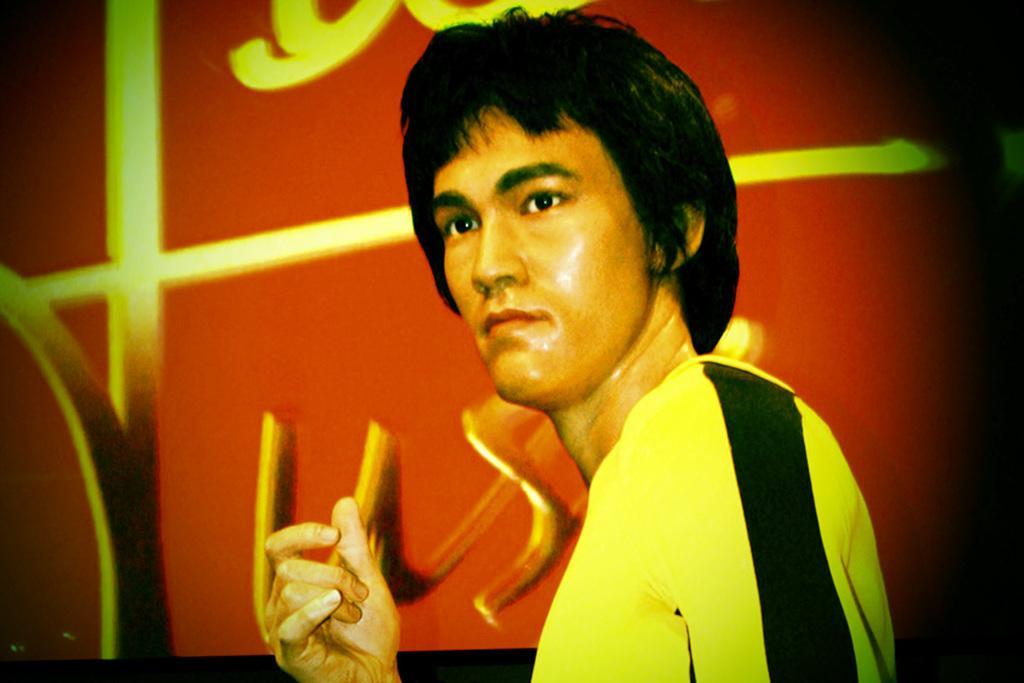In one or two sentences, can you explain what this image depicts? In the picture I can see a man who is wearing yellow and black color clothes. In the background I can see a red color object which has some designs. 